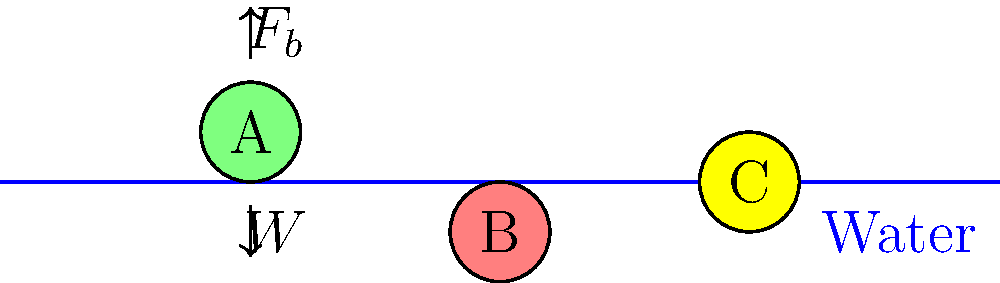As an art therapist developing a program to explore the connection between physics and emotional states, you want to use the principle of buoyancy as a metaphor. In the illustration, objects A, B, and C represent different emotional states. Which object best represents a balanced emotional state, and why does it remain at that position in the water? To answer this question, let's consider the principle of buoyancy and how it relates to emotional states:

1. Buoyancy principle: The buoyant force ($F_b$) exerted by a fluid on an object is equal to the weight of the fluid displaced by the object.

2. For an object to float, sink, or remain neutrally buoyant:
   - If $F_b > W$ (weight), the object floats (object A)
   - If $F_b < W$, the object sinks (object B)
   - If $F_b = W$, the object is neutrally buoyant (object C)

3. Object C represents a balanced emotional state because:
   - It remains at a constant depth, neither rising nor sinking
   - This suggests a balance between internal pressures (weight) and external support (buoyant force)

4. In terms of emotional metaphor:
   - The water represents the supporting environment
   - The object's weight represents internal challenges or stressors
   - The buoyant force represents external support or coping mechanisms

5. A balanced emotional state (object C) occurs when:
   - Internal challenges are perfectly matched by external support
   - The person neither feels overwhelmed (sinking) nor disconnected from their emotions (floating too high)

6. This balance allows for:
   - Stability in one's emotional state
   - The ability to navigate life's challenges without being submerged or overly detached

Therefore, object C best represents a balanced emotional state because it maintains a constant position in the water, symbolizing emotional equilibrium.
Answer: Object C; buoyant force equals weight, symbolizing balanced internal challenges and external support. 